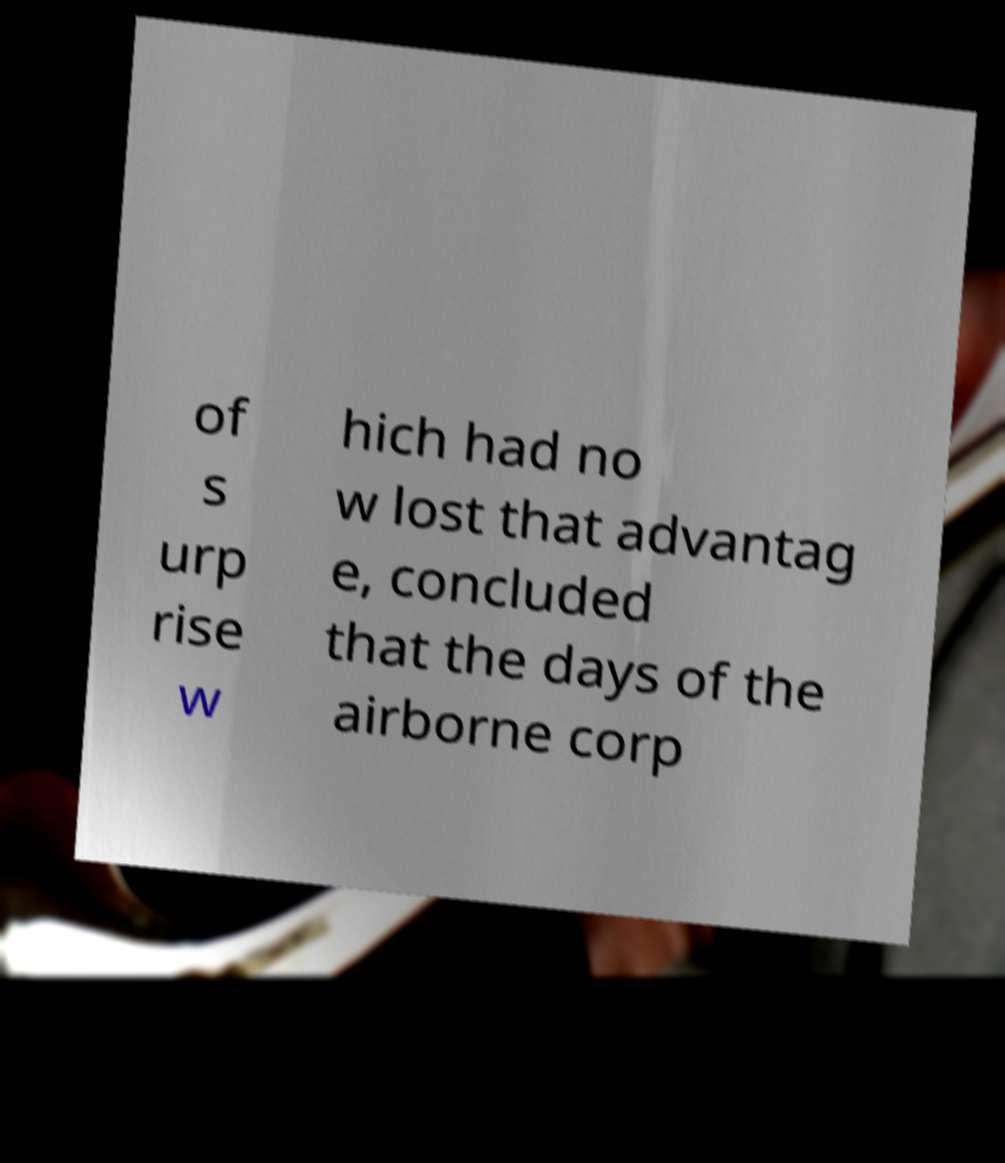There's text embedded in this image that I need extracted. Can you transcribe it verbatim? of s urp rise w hich had no w lost that advantag e, concluded that the days of the airborne corp 